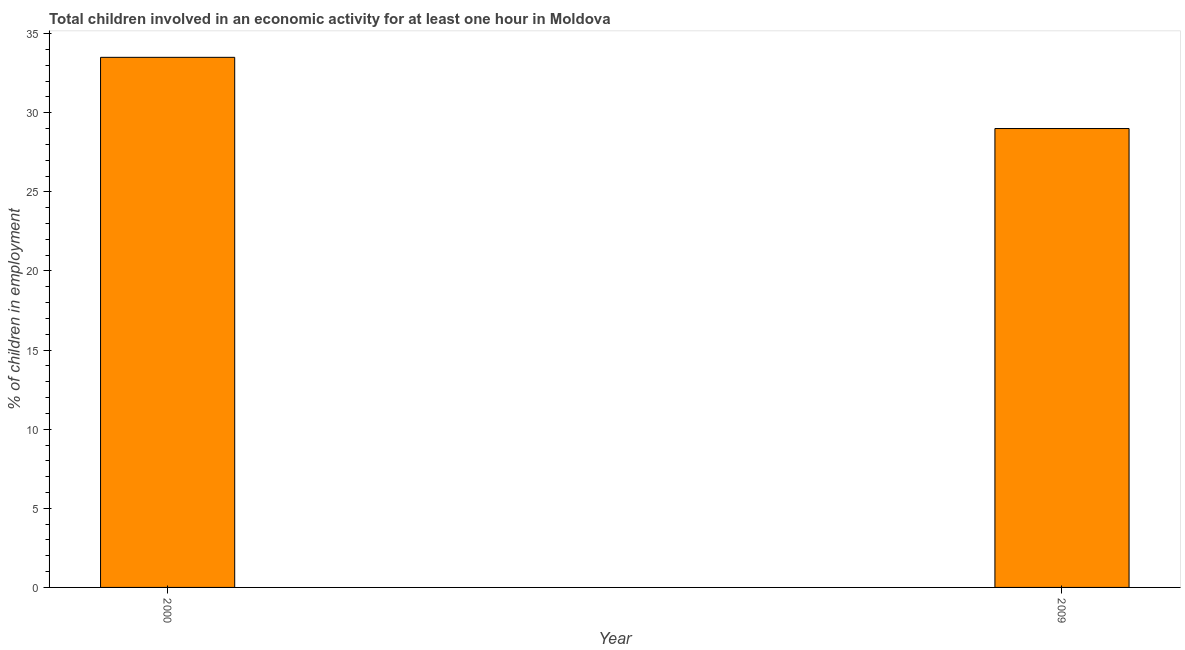Does the graph contain grids?
Ensure brevity in your answer.  No. What is the title of the graph?
Offer a terse response. Total children involved in an economic activity for at least one hour in Moldova. What is the label or title of the X-axis?
Give a very brief answer. Year. What is the label or title of the Y-axis?
Your response must be concise. % of children in employment. What is the percentage of children in employment in 2009?
Your response must be concise. 29. Across all years, what is the maximum percentage of children in employment?
Provide a short and direct response. 33.5. Across all years, what is the minimum percentage of children in employment?
Make the answer very short. 29. What is the sum of the percentage of children in employment?
Ensure brevity in your answer.  62.5. What is the average percentage of children in employment per year?
Provide a succinct answer. 31.25. What is the median percentage of children in employment?
Make the answer very short. 31.25. In how many years, is the percentage of children in employment greater than 22 %?
Keep it short and to the point. 2. Do a majority of the years between 2000 and 2009 (inclusive) have percentage of children in employment greater than 24 %?
Provide a short and direct response. Yes. What is the ratio of the percentage of children in employment in 2000 to that in 2009?
Make the answer very short. 1.16. In how many years, is the percentage of children in employment greater than the average percentage of children in employment taken over all years?
Ensure brevity in your answer.  1. Are the values on the major ticks of Y-axis written in scientific E-notation?
Provide a short and direct response. No. What is the % of children in employment in 2000?
Give a very brief answer. 33.5. What is the % of children in employment in 2009?
Keep it short and to the point. 29. What is the difference between the % of children in employment in 2000 and 2009?
Provide a short and direct response. 4.5. What is the ratio of the % of children in employment in 2000 to that in 2009?
Make the answer very short. 1.16. 